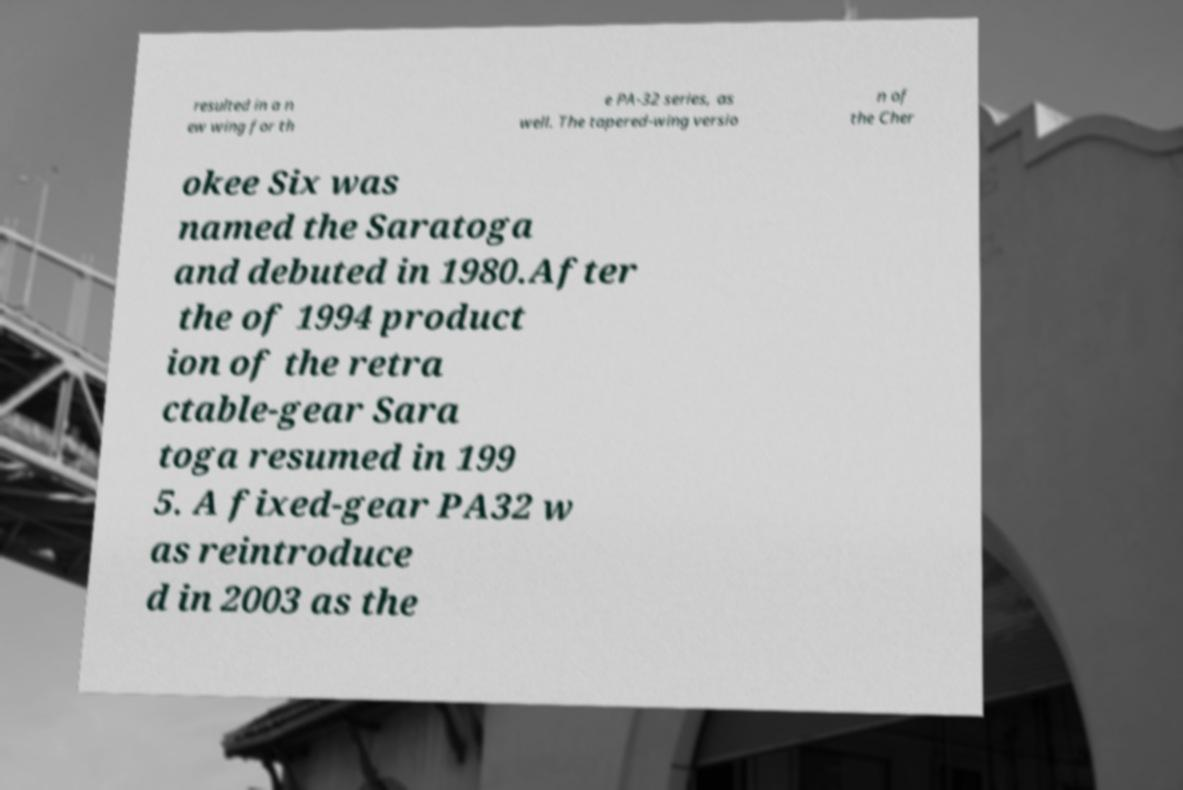Please identify and transcribe the text found in this image. resulted in a n ew wing for th e PA-32 series, as well. The tapered-wing versio n of the Cher okee Six was named the Saratoga and debuted in 1980.After the of 1994 product ion of the retra ctable-gear Sara toga resumed in 199 5. A fixed-gear PA32 w as reintroduce d in 2003 as the 